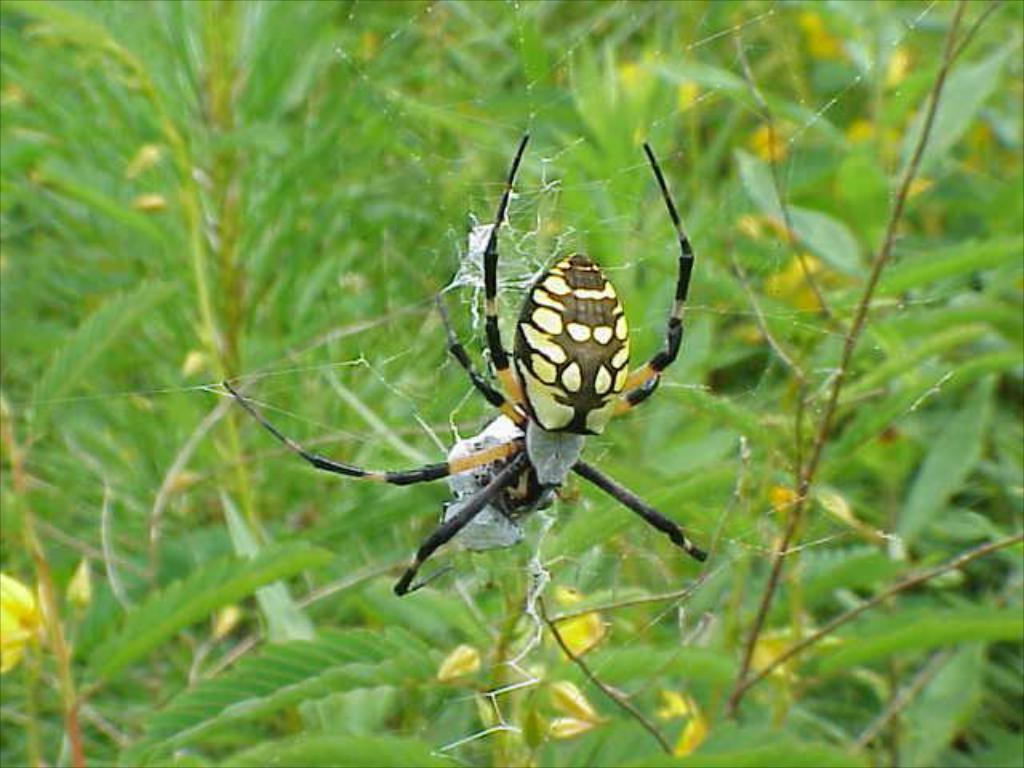What is the main subject of the image? There is a spider in the image. Where is the spider located? The spider is on a web. What else can be seen in the image besides the spider? There are plants visible in the image. What type of secretary can be seen working at the faucet in the image? There is no secretary or faucet present in the image; it features a spider on a web and plants. 